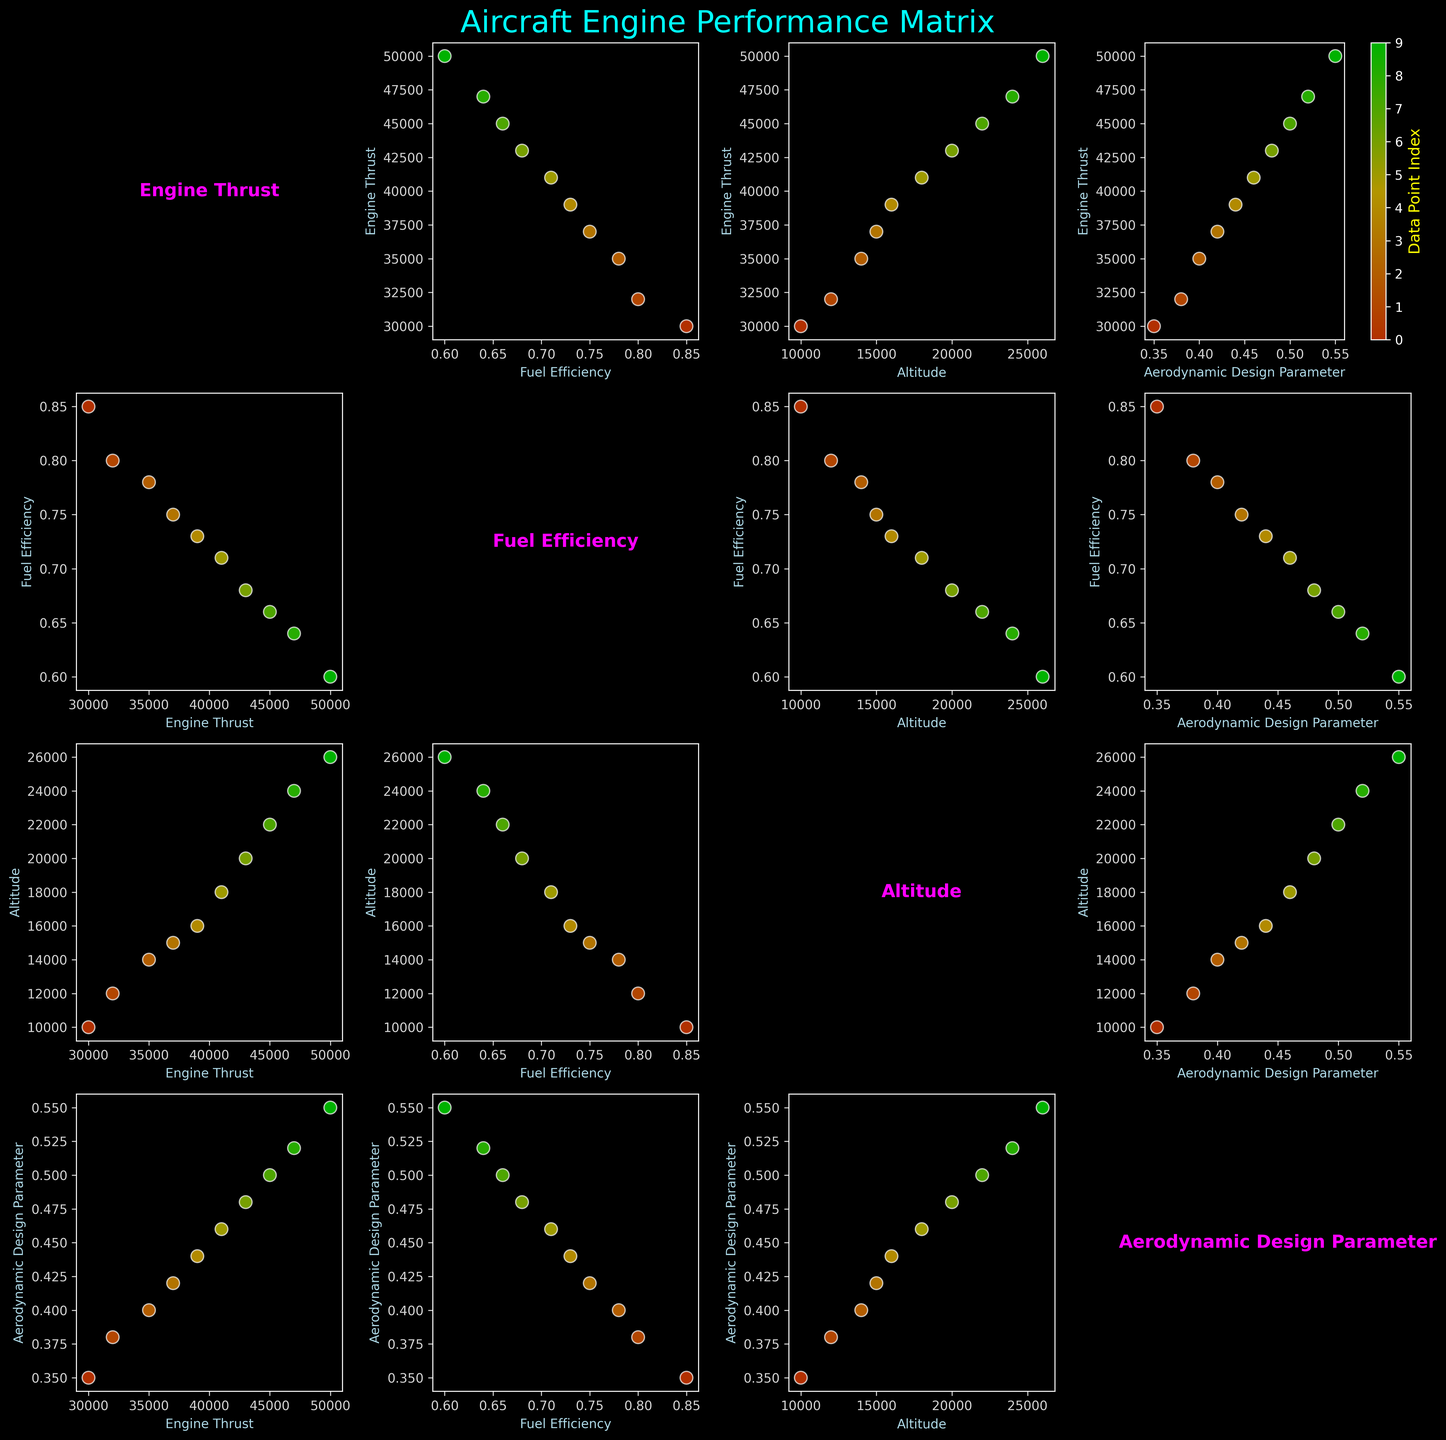What's the title of the figure? The title of the figure is at the top and centrally located. It reads 'Aircraft Engine Performance Matrix'.
Answer: Aircraft Engine Performance Matrix How many data points are there in the figure? By looking at any of the scatter plots, it can be observed that there are 10 distinct data points plotted.
Answer: 10 Which color represents the last data point in the color bar? Observing the color bar on the top-right scatter plot, the last data point is represented by a bright green color.
Answer: Bright green What is the general trend between Engine Thrust and Fuel Efficiency? By examining the scatter plot matrix panel of Engine Thrust vs. Fuel Efficiency, one can see that as Engine Thrust increases, Fuel Efficiency generally decreases.
Answer: Decreases What is the relationship between Altitude and Aerodynamic Design Parameter? Looking at the corresponding scatter plot, it is evident that there is a positive correlation; as Altitude increases, the Aerodynamic Design Parameter also tends to increase.
Answer: Positive correlation Is there any pairing of variables where the data points form a straight line? None of the scatter plots in the matrix reveal data points that form a perfectly straight line; rather, they exhibit various levels of scatter.
Answer: No Which scatter plot shows the highest variation in data points? The scatter plot comparing Altitude and Fuel Efficiency shows more distinct variation and wider spread among the data points.
Answer: Altitude vs. Fuel Efficiency Between Altitude and Fuel Efficiency, which one has a more noticeable linear trend with Engine Thrust? Assessing the scatter plots, Altitude has a more noticeable linear trend with Engine Thrust compared to Fuel Efficiency.
Answer: Altitude What can be inferred about the relationship between Engine Thrust and Aerodynamic Design Parameter? From the scatter plot, we can infer that there is a positive relationship; as Engine Thrust increases, so does the Aerodynamic Design Parameter.
Answer: Positive relationship How do Aerodynamic Design Parameter values change with increasing Altitude? The scatter plot for Altitude vs. Aerodynamic Design Parameter shows that as Altitude increases, the Aerodynamic Design Parameter values also increase evenly along the scale.
Answer: Increase 